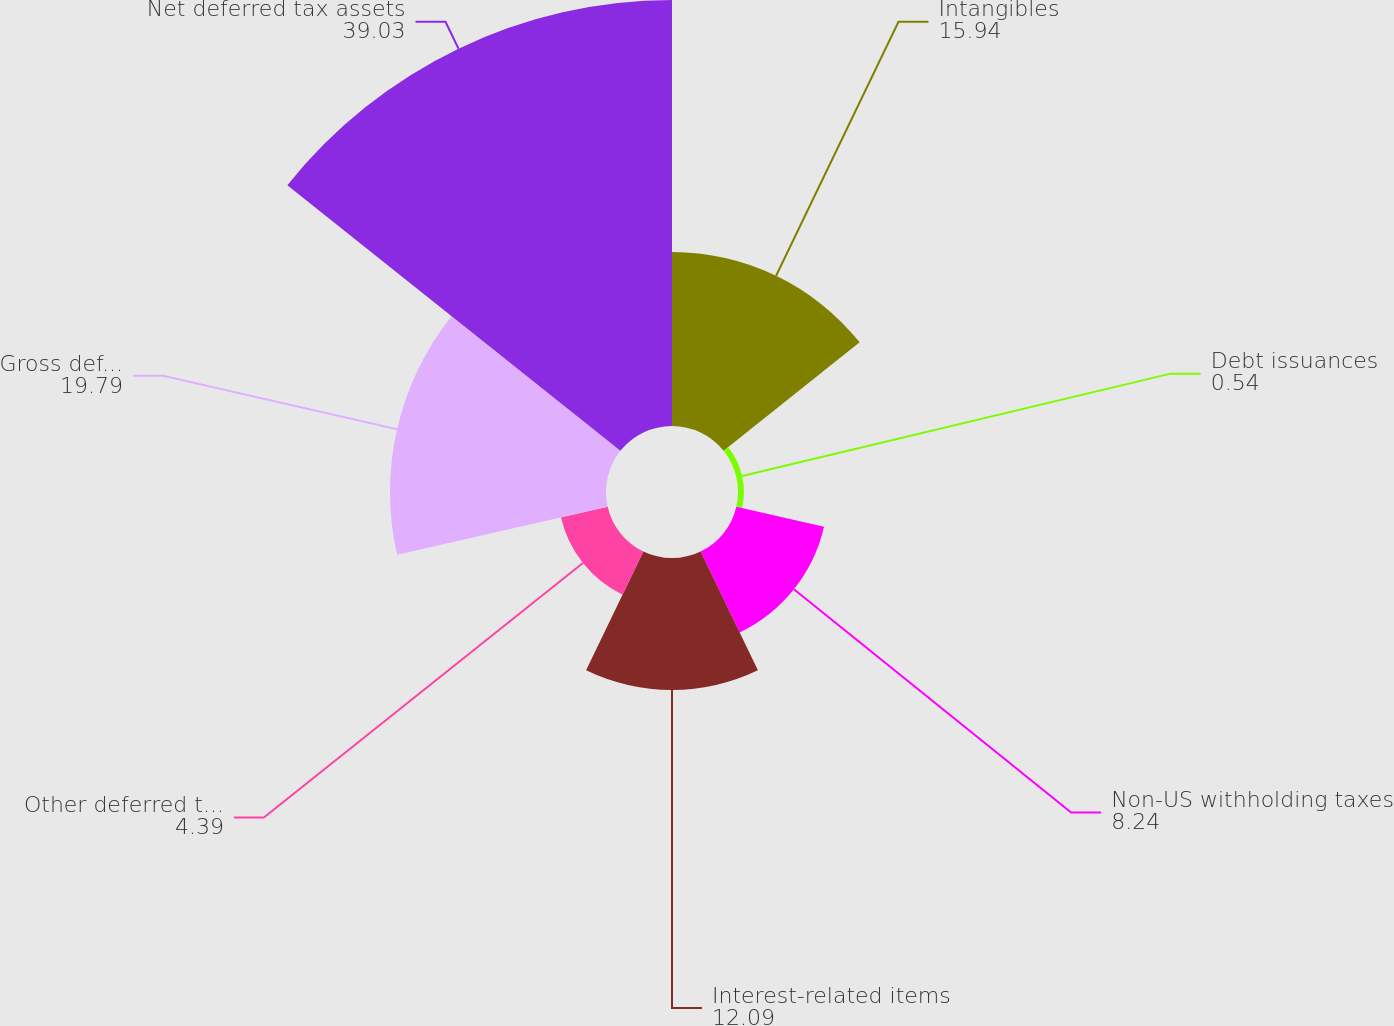Convert chart. <chart><loc_0><loc_0><loc_500><loc_500><pie_chart><fcel>Intangibles<fcel>Debt issuances<fcel>Non-US withholding taxes<fcel>Interest-related items<fcel>Other deferred tax liabilities<fcel>Gross deferred tax liabilities<fcel>Net deferred tax assets<nl><fcel>15.94%<fcel>0.54%<fcel>8.24%<fcel>12.09%<fcel>4.39%<fcel>19.79%<fcel>39.03%<nl></chart> 